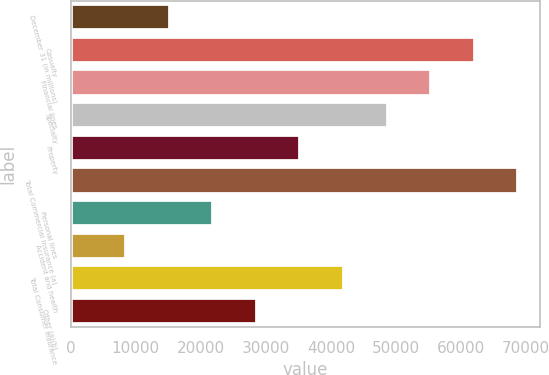Convert chart. <chart><loc_0><loc_0><loc_500><loc_500><bar_chart><fcel>December 31 (in millions)<fcel>Casualty<fcel>Financial lines<fcel>Specialty<fcel>Property<fcel>Total Commercial Insurance (a)<fcel>Personal lines<fcel>Accident and health<fcel>Total Consumer Insurance<fcel>Other (a)(b)<nl><fcel>15222.8<fcel>62087.1<fcel>55392.2<fcel>48697.3<fcel>35307.5<fcel>68782<fcel>21917.7<fcel>8527.9<fcel>42002.4<fcel>28612.6<nl></chart> 